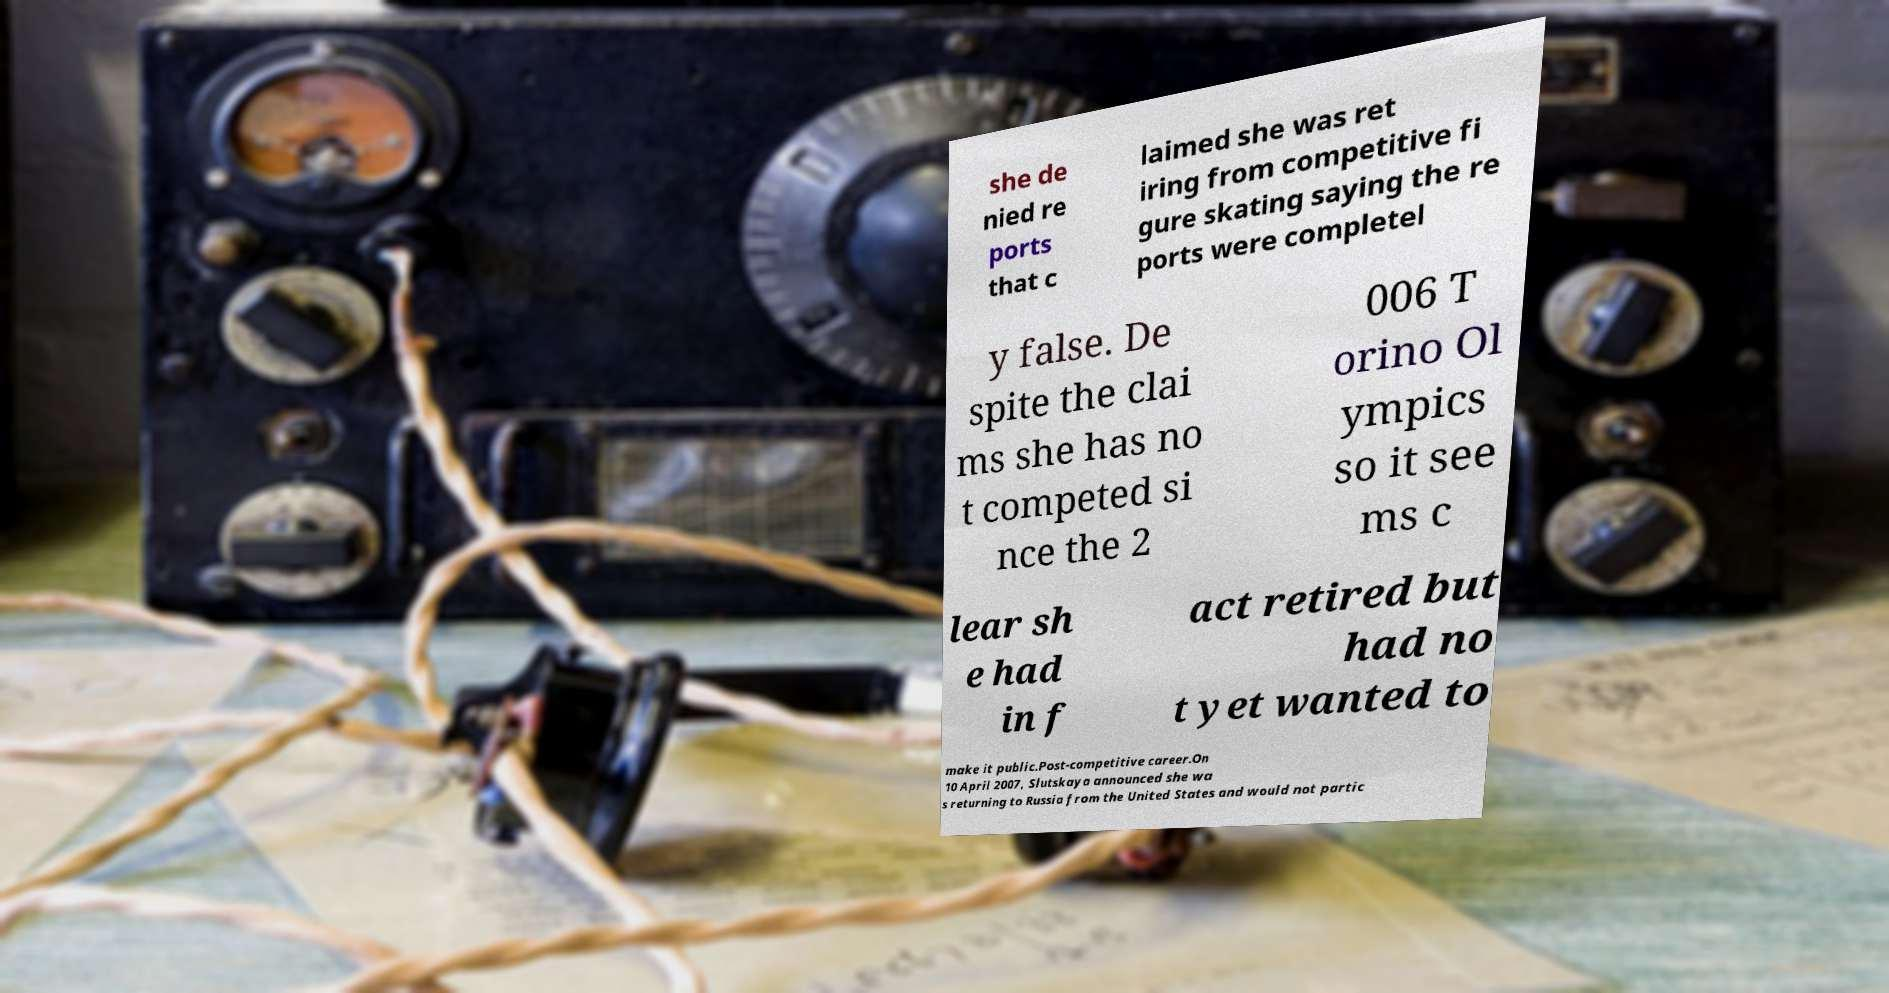Could you assist in decoding the text presented in this image and type it out clearly? she de nied re ports that c laimed she was ret iring from competitive fi gure skating saying the re ports were completel y false. De spite the clai ms she has no t competed si nce the 2 006 T orino Ol ympics so it see ms c lear sh e had in f act retired but had no t yet wanted to make it public.Post-competitive career.On 10 April 2007, Slutskaya announced she wa s returning to Russia from the United States and would not partic 